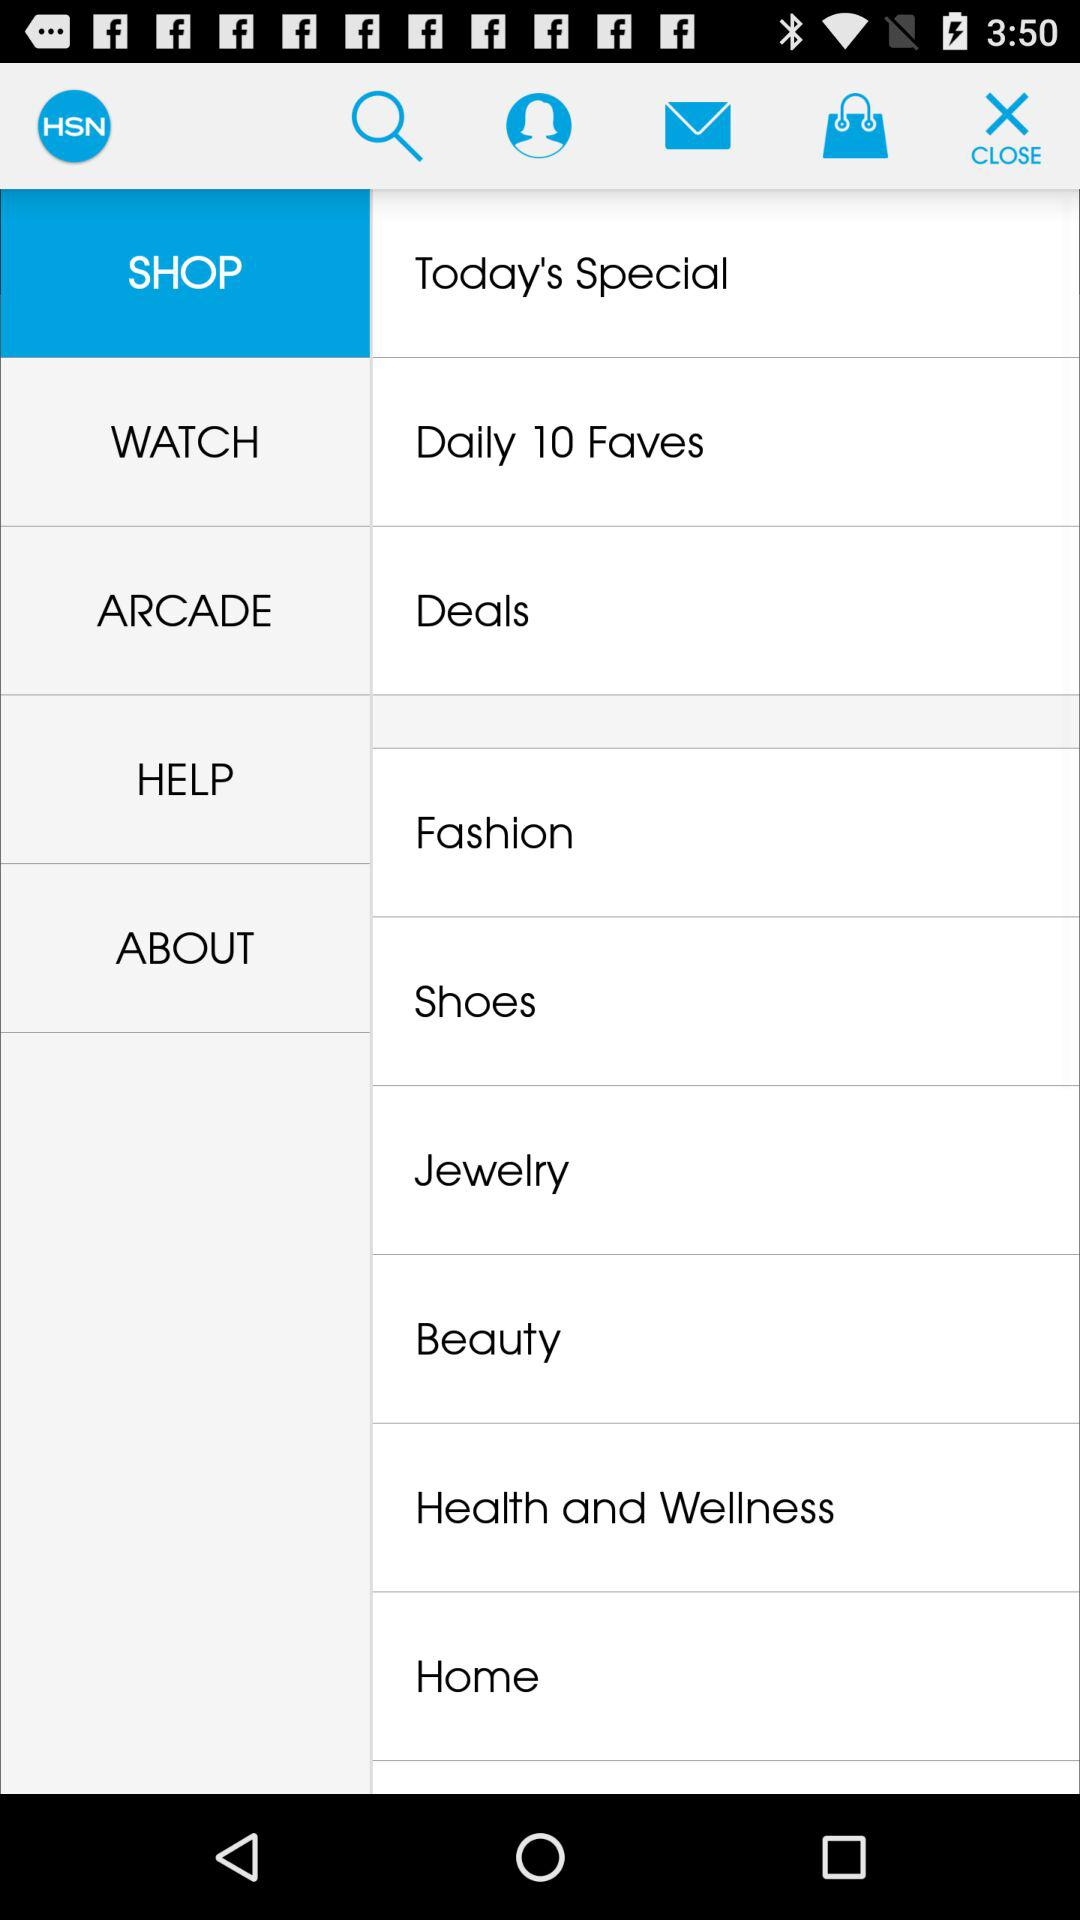What is the name of the application? The name of the application is "HSN". 